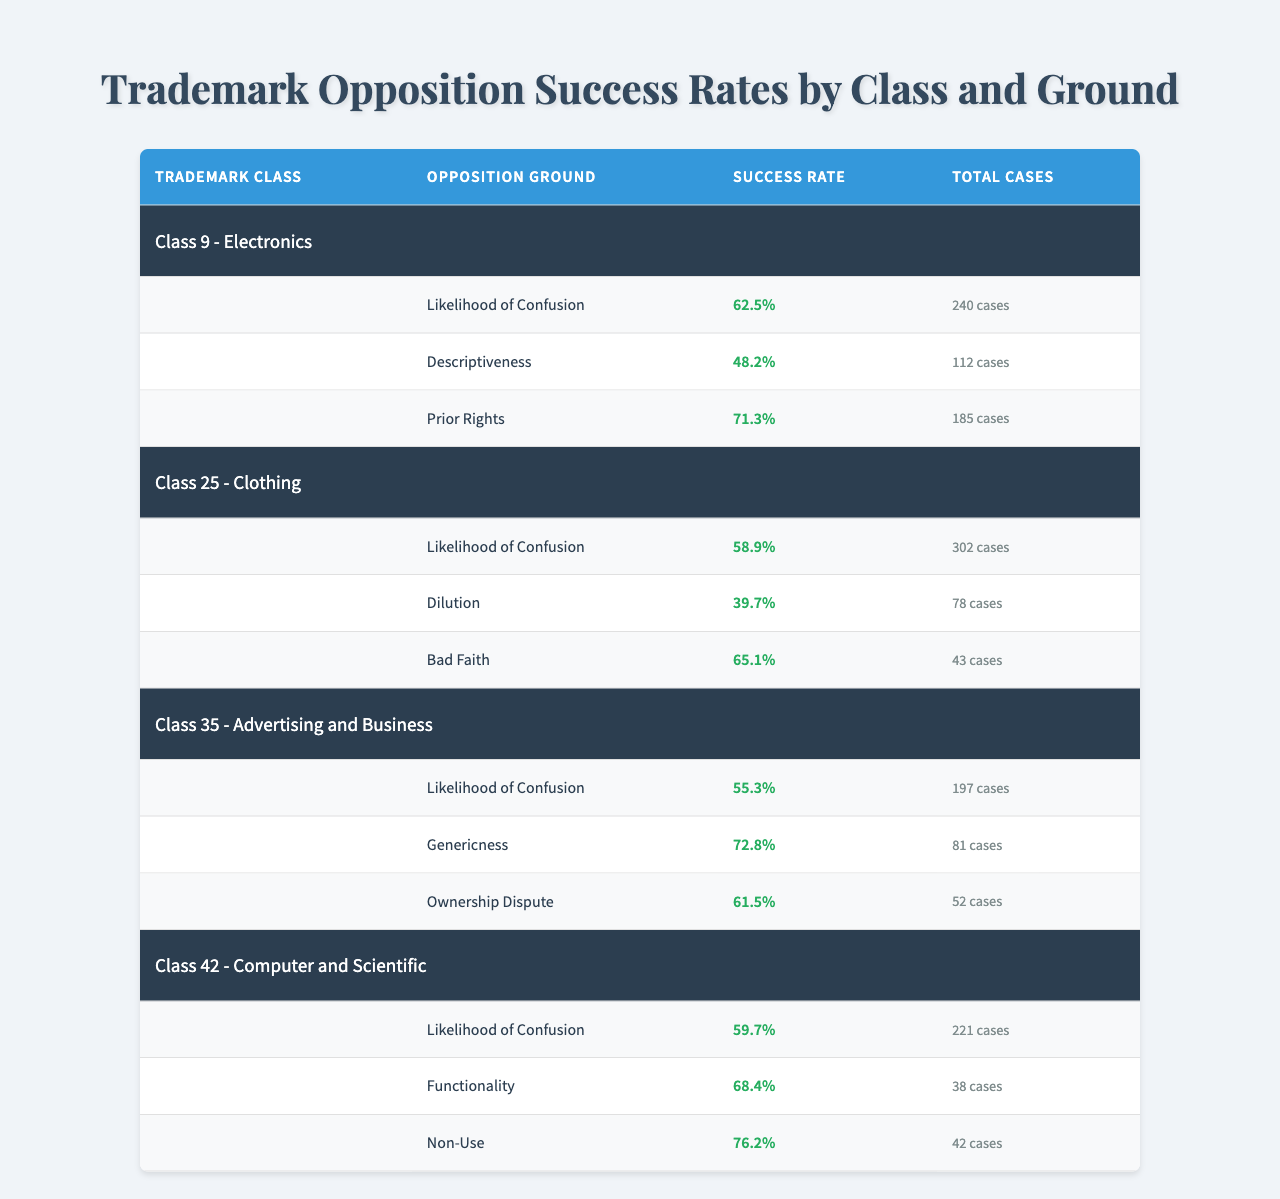What's the success rate for "Likelihood of Confusion" in Class 9? The success rate for "Likelihood of Confusion" is specifically listed in the table under Class 9, which shows it as 62.5%.
Answer: 62.5% Which opposition ground has the highest success rate in Class 25? In Class 25, if we compare the success rates, "Bad Faith" has the highest rate at 65.1%, while "Dilution" has the lowest at 39.7%.
Answer: Bad Faith How many total cases were cited for "Descriptiveness" in Class 9? The table indicates that there were 112 total cases cited for the ground "Descriptiveness" under Class 9.
Answer: 112 What is the average success rate for all grounds in Class 42? The success rates in Class 42 are 59.7%, 68.4%, and 76.2%. Adding these gives 204.3%, and dividing by 3 for the average results in approximately 68.1%.
Answer: 68.1% Is the success rate for "Genericness" higher than that for "Dilution" in any trademark class? In Class 35, the success rate for "Genericness" is 72.8%, which is higher than "Dilution" in Class 25 with a success rate of 39.7%.
Answer: Yes What ground has the lowest success rate in Class 35? The ground with the lowest success rate in Class 35 is "Likelihood of Confusion," which has a success rate of 55.3% compared to the others.
Answer: Likelihood of Confusion How many total cases were evaluated for Class 42? By adding the total cases from all grounds in Class 42 (221 + 38 + 42 = 301), we find that there were 301 cases evaluated.
Answer: 301 Which trademark class has the highest overall success rate across its grounds? By calculating the average success rates for each class: Class 9 (60.6%), Class 25 (54.5%), Class 35 (62.5%), and Class 42 (68.1%), Class 42 has the highest average.
Answer: Class 42 What is the difference in success rate between "Prior Rights" in Class 9 and "Ownership Dispute" in Class 35? The success rate for "Prior Rights" in Class 9 is 71.3%, and for "Ownership Dispute" in Class 35, it is 61.5%. The difference is 71.3% - 61.5% = 9.8%.
Answer: 9.8% Are there more total cases in Class 25 than in Class 9? Class 9 has a total of 240 cases, while Class 25 has 302 cases, which verifies there are more cases in Class 25.
Answer: Yes 